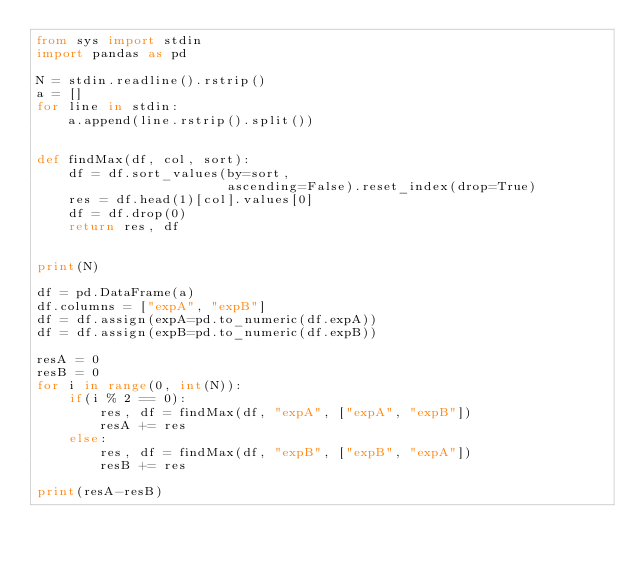Convert code to text. <code><loc_0><loc_0><loc_500><loc_500><_Python_>from sys import stdin
import pandas as pd

N = stdin.readline().rstrip()
a = []
for line in stdin:
    a.append(line.rstrip().split())


def findMax(df, col, sort):
    df = df.sort_values(by=sort,
                        ascending=False).reset_index(drop=True)
    res = df.head(1)[col].values[0]
    df = df.drop(0)
    return res, df


print(N)

df = pd.DataFrame(a)
df.columns = ["expA", "expB"]
df = df.assign(expA=pd.to_numeric(df.expA))
df = df.assign(expB=pd.to_numeric(df.expB))

resA = 0
resB = 0
for i in range(0, int(N)):
    if(i % 2 == 0):
        res, df = findMax(df, "expA", ["expA", "expB"])
        resA += res
    else:
        res, df = findMax(df, "expB", ["expB", "expA"])
        resB += res

print(resA-resB)
</code> 